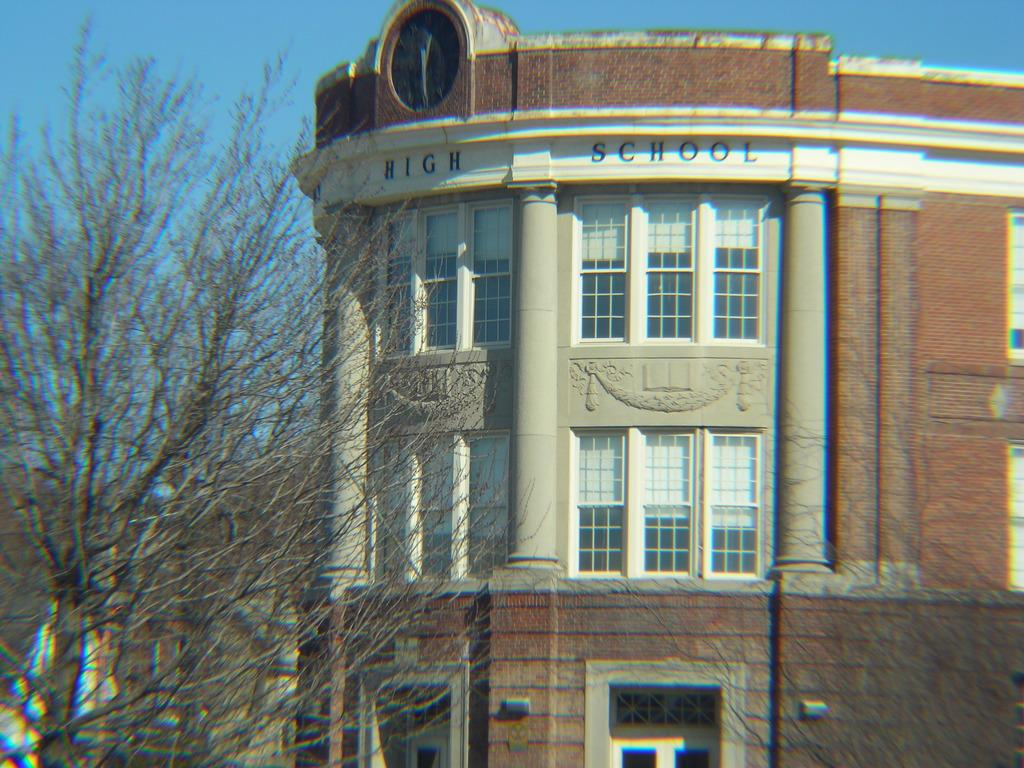What type of structure is present in the image? There is a building in the image. What feature can be observed on the building? The building has glass windows. What color is the wall of the building? The wall of the building is in brown color. What is located in front of the building? There are dry trees in front of the building. What is the color of the sky in the image? The sky is blue in the image. What object can be used to tell time in the image? There is a clock visible in the image. What invention is being used to destroy the building in the image? There is no destruction or invention present in the image; the building appears to be intact. 